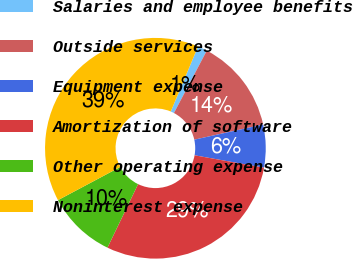Convert chart to OTSL. <chart><loc_0><loc_0><loc_500><loc_500><pie_chart><fcel>Salaries and employee benefits<fcel>Outside services<fcel>Equipment expense<fcel>Amortization of software<fcel>Other operating expense<fcel>Noninterest expense<nl><fcel>1.4%<fcel>13.83%<fcel>6.28%<fcel>29.33%<fcel>10.06%<fcel>39.11%<nl></chart> 